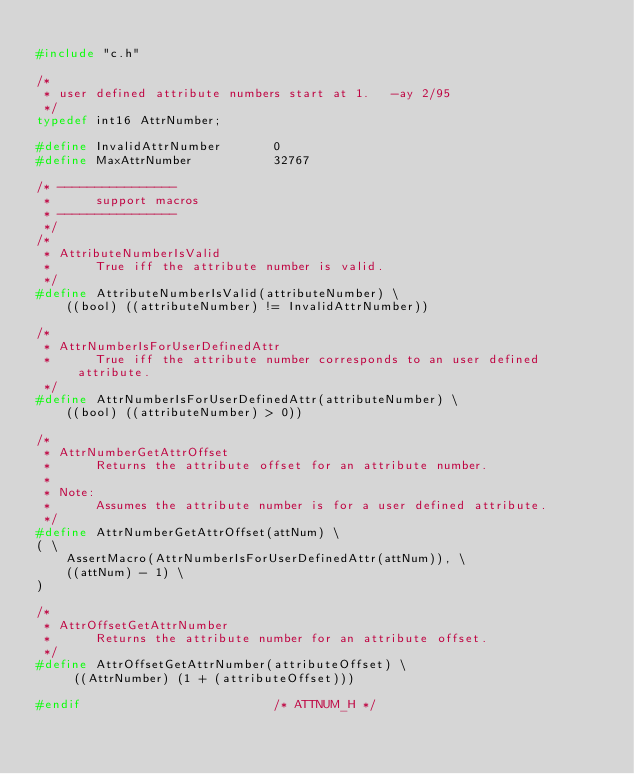<code> <loc_0><loc_0><loc_500><loc_500><_C_>
#include "c.h"

/*
 * user defined attribute numbers start at 1.   -ay 2/95
 */
typedef int16 AttrNumber;

#define InvalidAttrNumber		0
#define MaxAttrNumber			32767

/* ----------------
 *		support macros
 * ----------------
 */
/*
 * AttributeNumberIsValid
 *		True iff the attribute number is valid.
 */
#define AttributeNumberIsValid(attributeNumber) \
	((bool) ((attributeNumber) != InvalidAttrNumber))

/*
 * AttrNumberIsForUserDefinedAttr
 *		True iff the attribute number corresponds to an user defined attribute.
 */
#define AttrNumberIsForUserDefinedAttr(attributeNumber) \
	((bool) ((attributeNumber) > 0))

/*
 * AttrNumberGetAttrOffset
 *		Returns the attribute offset for an attribute number.
 *
 * Note:
 *		Assumes the attribute number is for a user defined attribute.
 */
#define AttrNumberGetAttrOffset(attNum) \
( \
	AssertMacro(AttrNumberIsForUserDefinedAttr(attNum)), \
	((attNum) - 1) \
)

/*
 * AttrOffsetGetAttrNumber
 *		Returns the attribute number for an attribute offset.
 */
#define AttrOffsetGetAttrNumber(attributeOffset) \
	 ((AttrNumber) (1 + (attributeOffset)))

#endif							/* ATTNUM_H */
</code> 